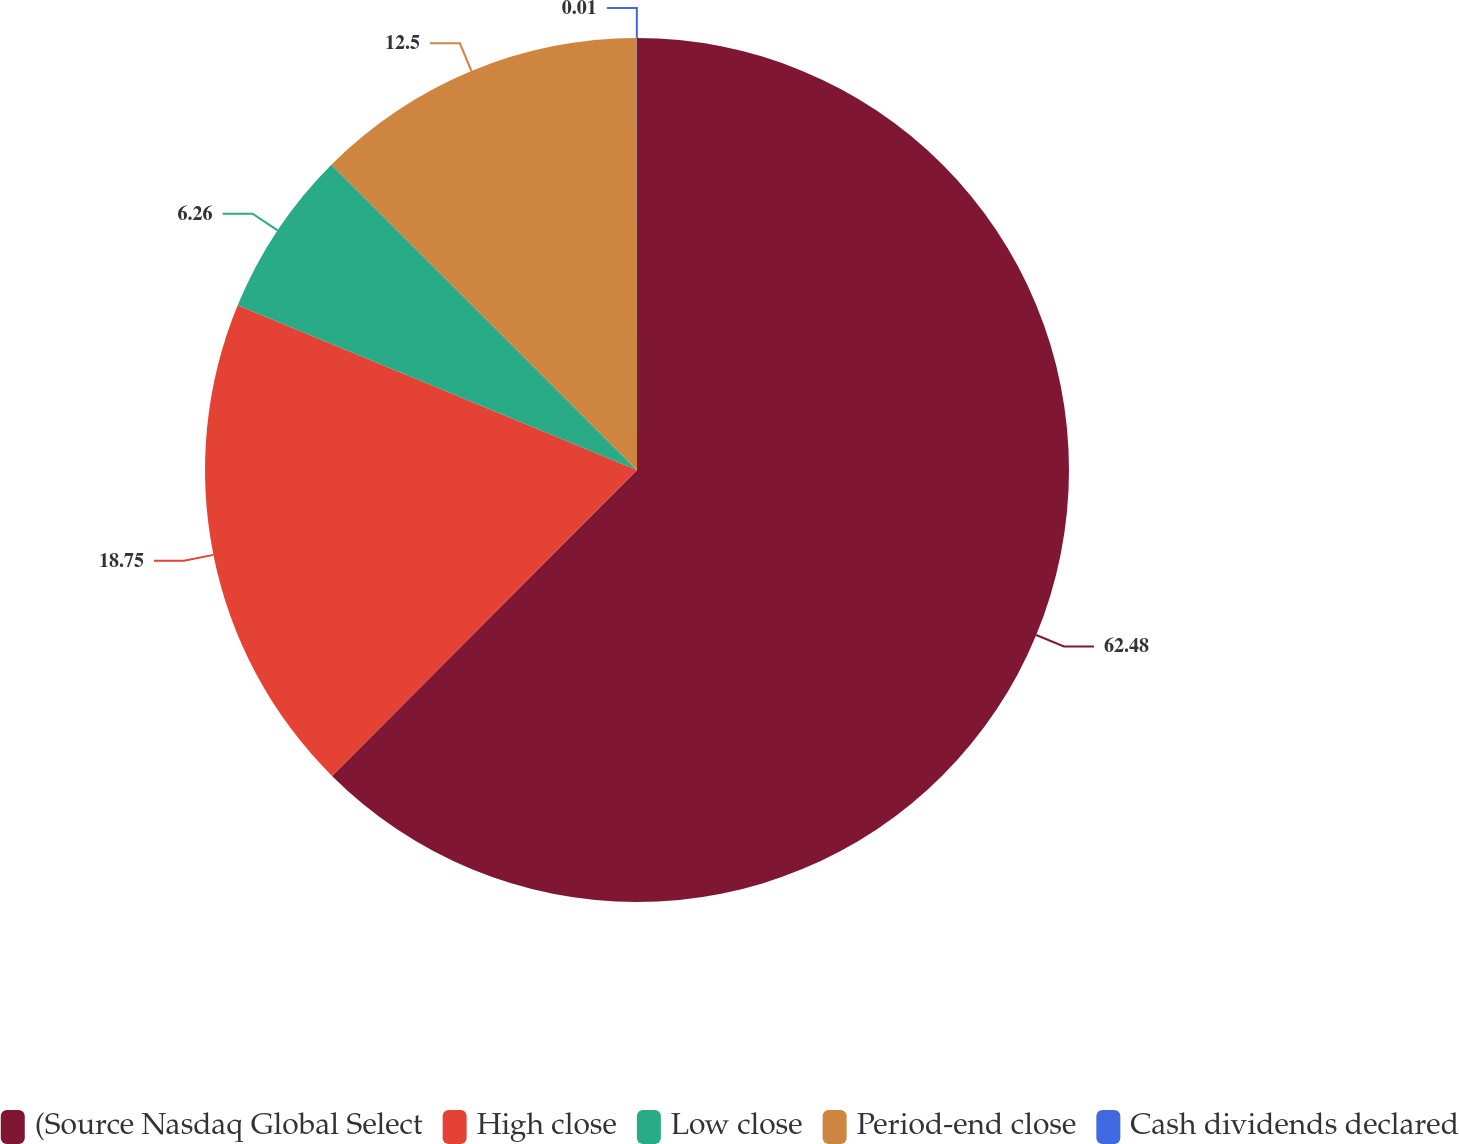<chart> <loc_0><loc_0><loc_500><loc_500><pie_chart><fcel>(Source Nasdaq Global Select<fcel>High close<fcel>Low close<fcel>Period-end close<fcel>Cash dividends declared<nl><fcel>62.47%<fcel>18.75%<fcel>6.26%<fcel>12.5%<fcel>0.01%<nl></chart> 